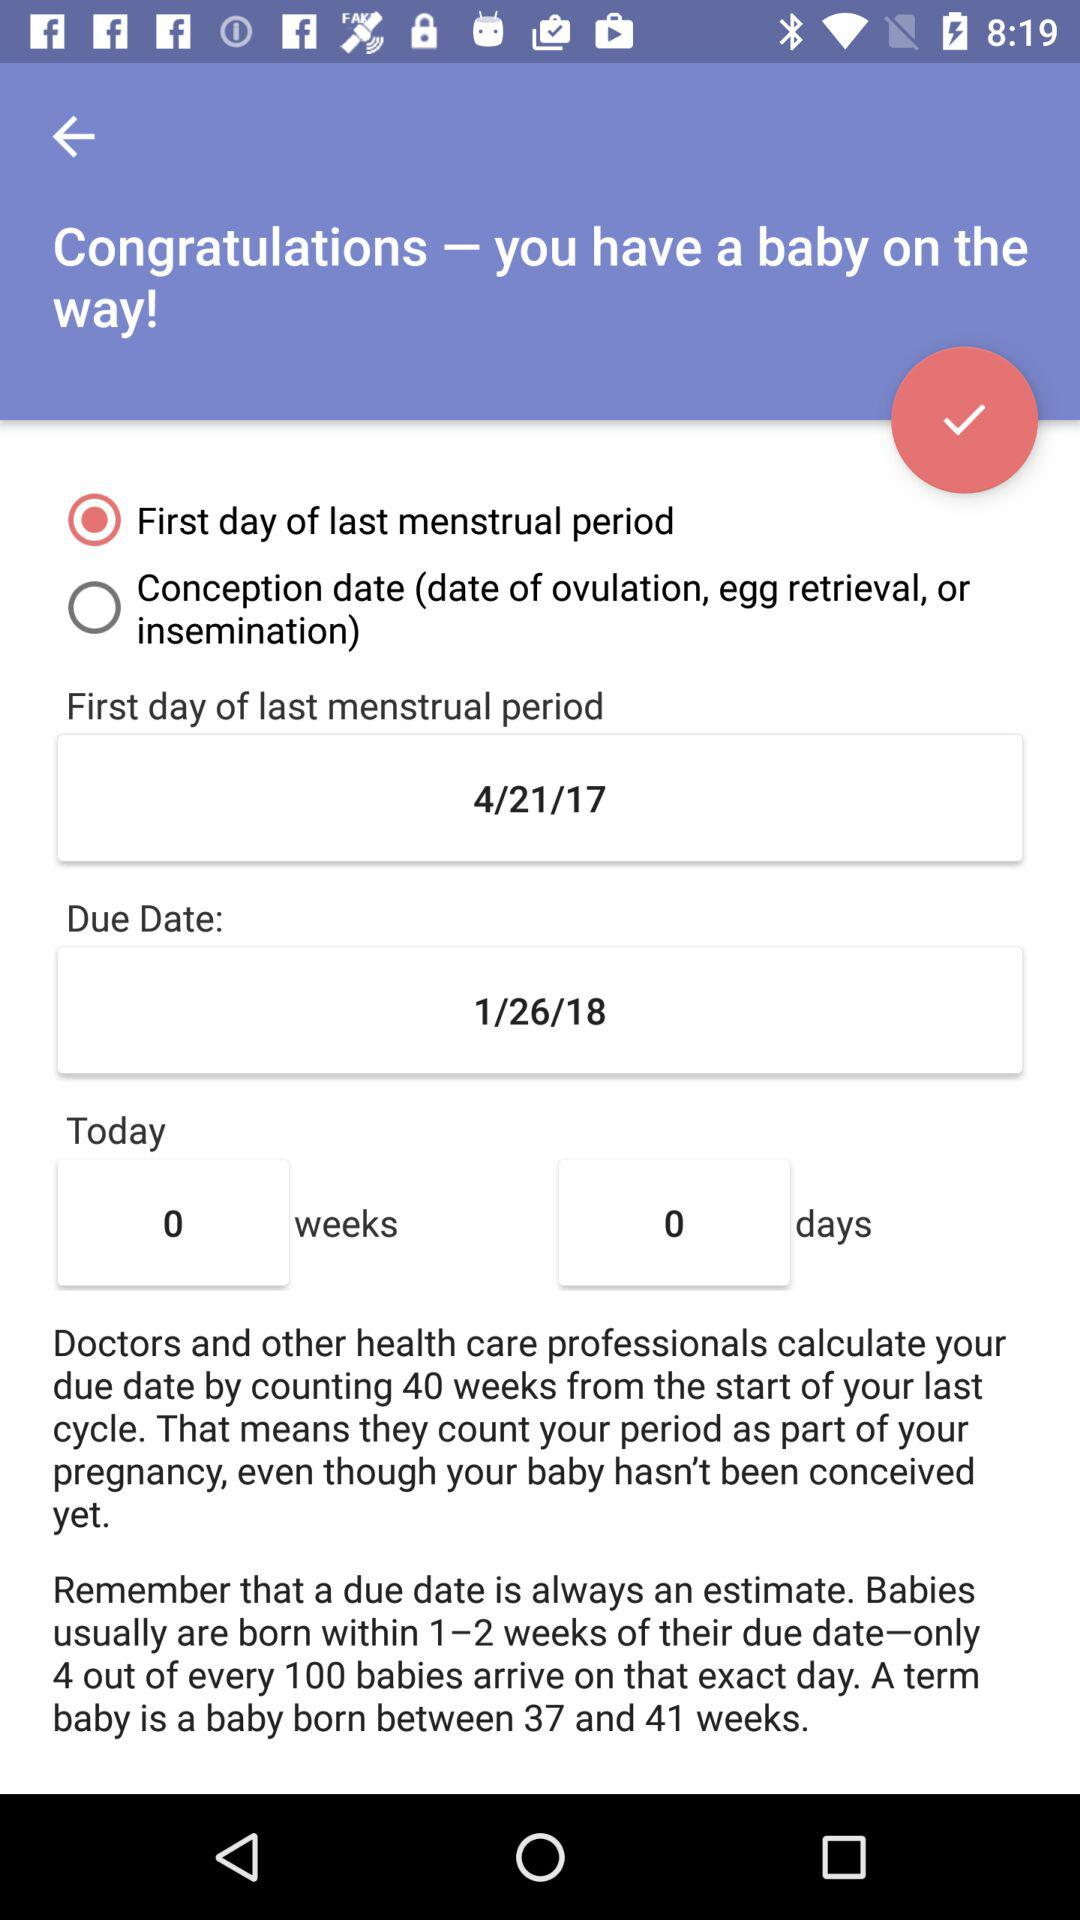How many weeks are there? There are 0 weeks. 